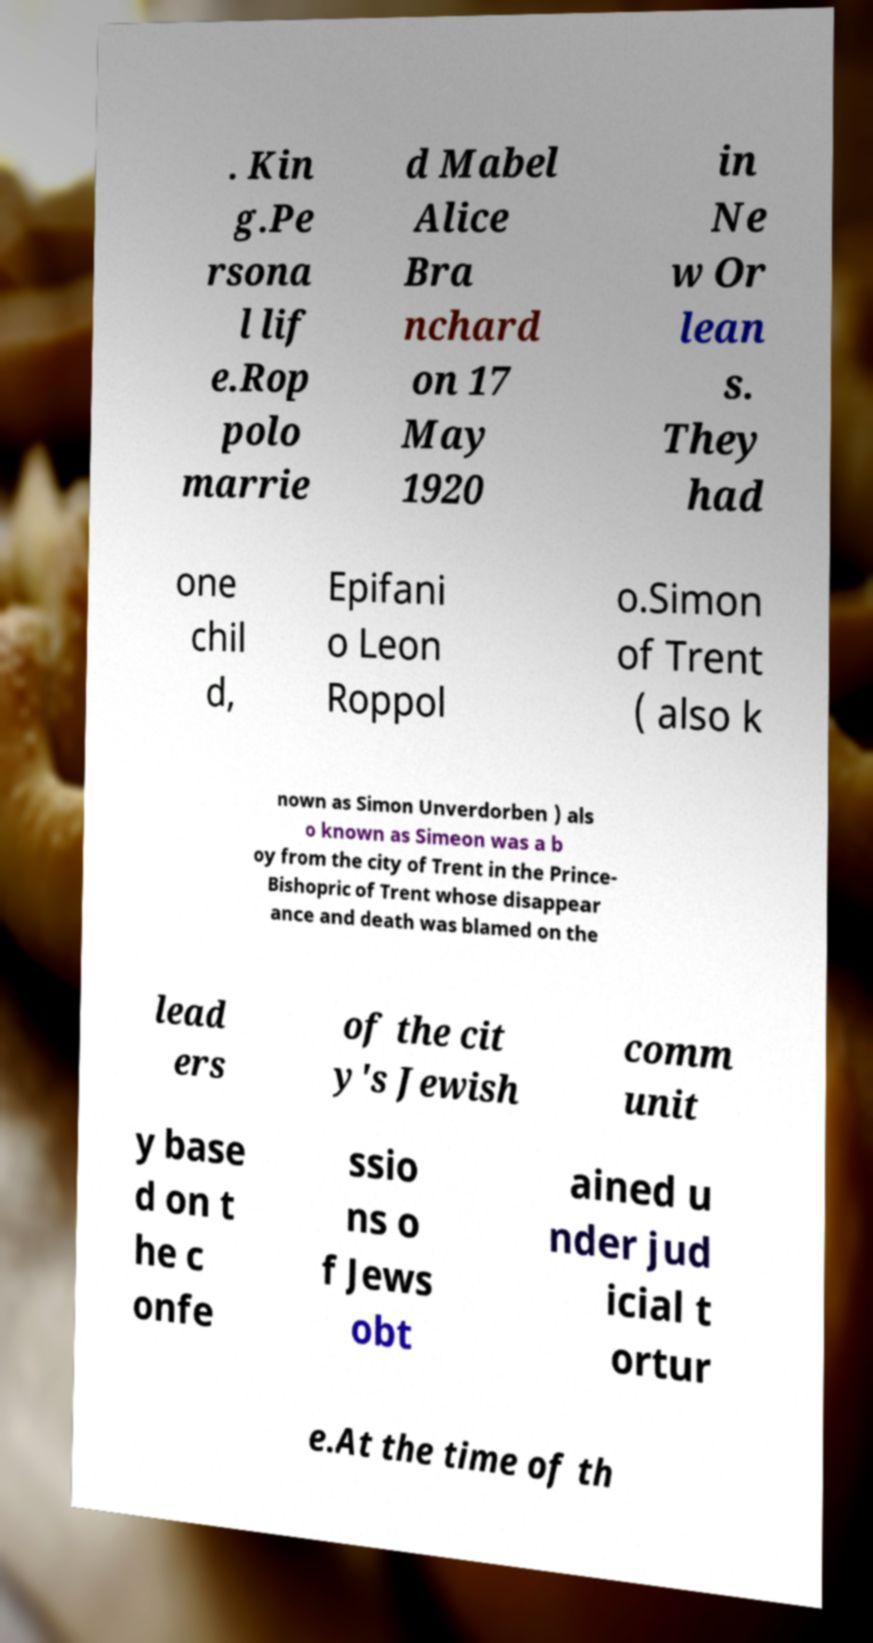There's text embedded in this image that I need extracted. Can you transcribe it verbatim? . Kin g.Pe rsona l lif e.Rop polo marrie d Mabel Alice Bra nchard on 17 May 1920 in Ne w Or lean s. They had one chil d, Epifani o Leon Roppol o.Simon of Trent ( also k nown as Simon Unverdorben ) als o known as Simeon was a b oy from the city of Trent in the Prince- Bishopric of Trent whose disappear ance and death was blamed on the lead ers of the cit y's Jewish comm unit y base d on t he c onfe ssio ns o f Jews obt ained u nder jud icial t ortur e.At the time of th 